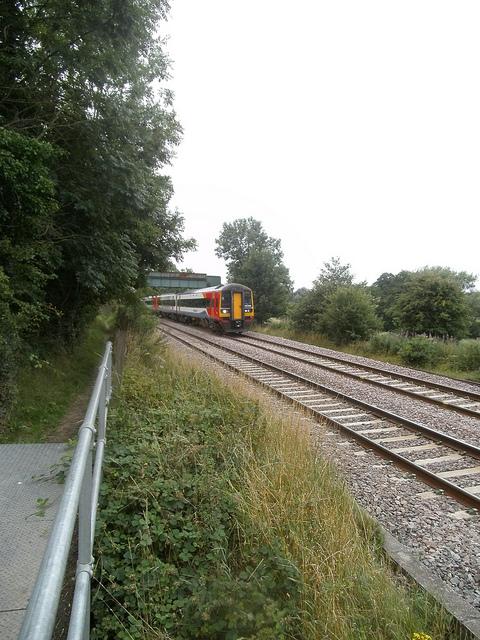What color is the gravel around the railroad tracks?
Answer briefly. Gray. How many railroad tracks are there?
Answer briefly. 2. What powers the engine in this photo?
Be succinct. Coal. What color is the first car on the train?
Concise answer only. Red. 